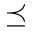Convert formula to latex. <formula><loc_0><loc_0><loc_500><loc_500>\preceq</formula> 